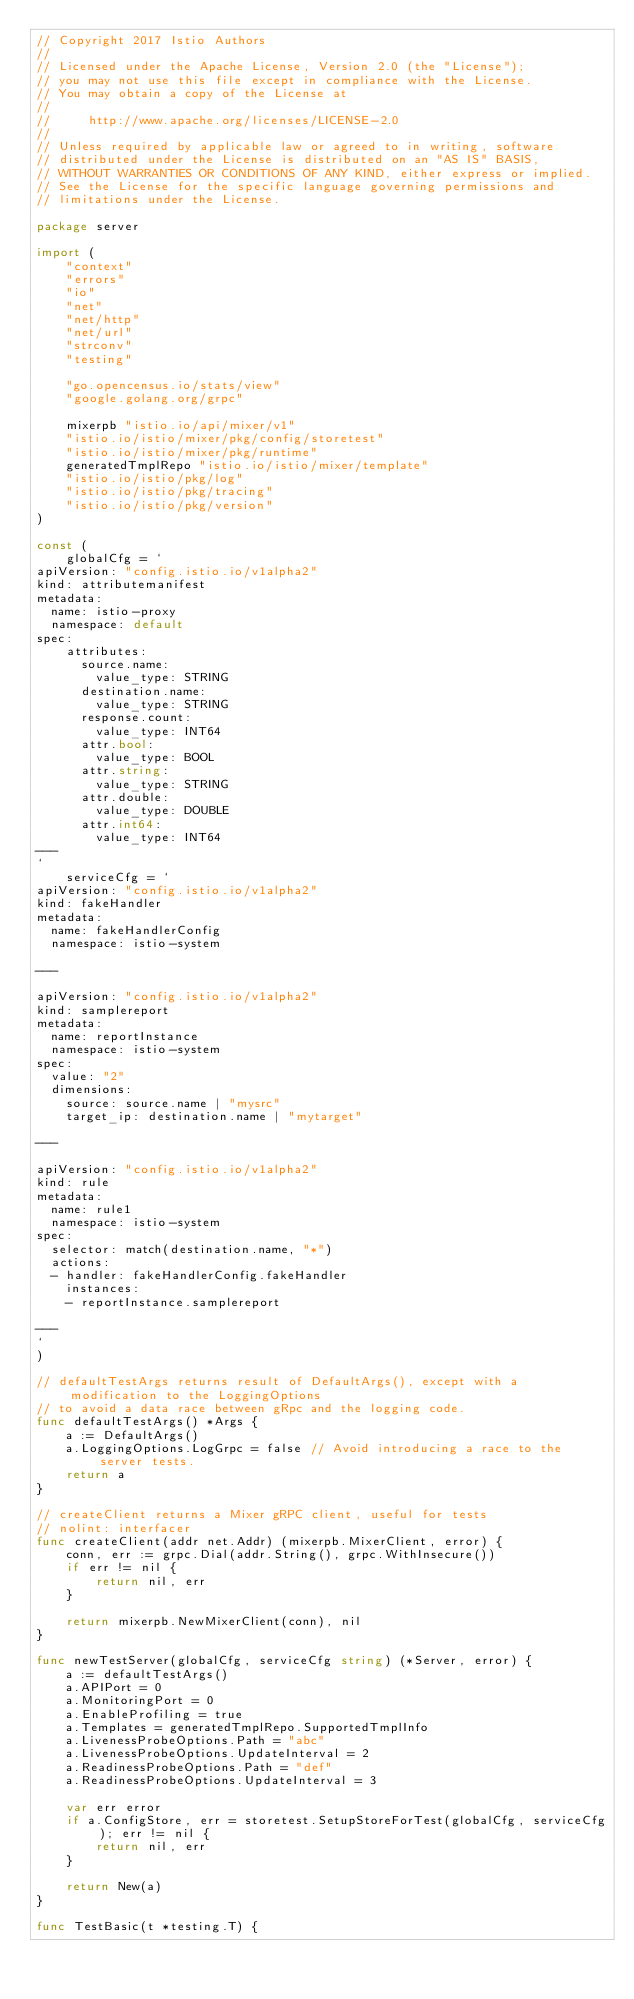<code> <loc_0><loc_0><loc_500><loc_500><_Go_>// Copyright 2017 Istio Authors
//
// Licensed under the Apache License, Version 2.0 (the "License");
// you may not use this file except in compliance with the License.
// You may obtain a copy of the License at
//
//     http://www.apache.org/licenses/LICENSE-2.0
//
// Unless required by applicable law or agreed to in writing, software
// distributed under the License is distributed on an "AS IS" BASIS,
// WITHOUT WARRANTIES OR CONDITIONS OF ANY KIND, either express or implied.
// See the License for the specific language governing permissions and
// limitations under the License.

package server

import (
	"context"
	"errors"
	"io"
	"net"
	"net/http"
	"net/url"
	"strconv"
	"testing"

	"go.opencensus.io/stats/view"
	"google.golang.org/grpc"

	mixerpb "istio.io/api/mixer/v1"
	"istio.io/istio/mixer/pkg/config/storetest"
	"istio.io/istio/mixer/pkg/runtime"
	generatedTmplRepo "istio.io/istio/mixer/template"
	"istio.io/istio/pkg/log"
	"istio.io/istio/pkg/tracing"
	"istio.io/istio/pkg/version"
)

const (
	globalCfg = `
apiVersion: "config.istio.io/v1alpha2"
kind: attributemanifest
metadata:
  name: istio-proxy
  namespace: default
spec:
    attributes:
      source.name:
        value_type: STRING
      destination.name:
        value_type: STRING
      response.count:
        value_type: INT64
      attr.bool:
        value_type: BOOL
      attr.string:
        value_type: STRING
      attr.double:
        value_type: DOUBLE
      attr.int64:
        value_type: INT64
---
`
	serviceCfg = `
apiVersion: "config.istio.io/v1alpha2"
kind: fakeHandler
metadata:
  name: fakeHandlerConfig
  namespace: istio-system

---

apiVersion: "config.istio.io/v1alpha2"
kind: samplereport
metadata:
  name: reportInstance
  namespace: istio-system
spec:
  value: "2"
  dimensions:
    source: source.name | "mysrc"
    target_ip: destination.name | "mytarget"

---

apiVersion: "config.istio.io/v1alpha2"
kind: rule
metadata:
  name: rule1
  namespace: istio-system
spec:
  selector: match(destination.name, "*")
  actions:
  - handler: fakeHandlerConfig.fakeHandler
    instances:
    - reportInstance.samplereport

---
`
)

// defaultTestArgs returns result of DefaultArgs(), except with a modification to the LoggingOptions
// to avoid a data race between gRpc and the logging code.
func defaultTestArgs() *Args {
	a := DefaultArgs()
	a.LoggingOptions.LogGrpc = false // Avoid introducing a race to the server tests.
	return a
}

// createClient returns a Mixer gRPC client, useful for tests
// nolint: interfacer
func createClient(addr net.Addr) (mixerpb.MixerClient, error) {
	conn, err := grpc.Dial(addr.String(), grpc.WithInsecure())
	if err != nil {
		return nil, err
	}

	return mixerpb.NewMixerClient(conn), nil
}

func newTestServer(globalCfg, serviceCfg string) (*Server, error) {
	a := defaultTestArgs()
	a.APIPort = 0
	a.MonitoringPort = 0
	a.EnableProfiling = true
	a.Templates = generatedTmplRepo.SupportedTmplInfo
	a.LivenessProbeOptions.Path = "abc"
	a.LivenessProbeOptions.UpdateInterval = 2
	a.ReadinessProbeOptions.Path = "def"
	a.ReadinessProbeOptions.UpdateInterval = 3

	var err error
	if a.ConfigStore, err = storetest.SetupStoreForTest(globalCfg, serviceCfg); err != nil {
		return nil, err
	}

	return New(a)
}

func TestBasic(t *testing.T) {</code> 